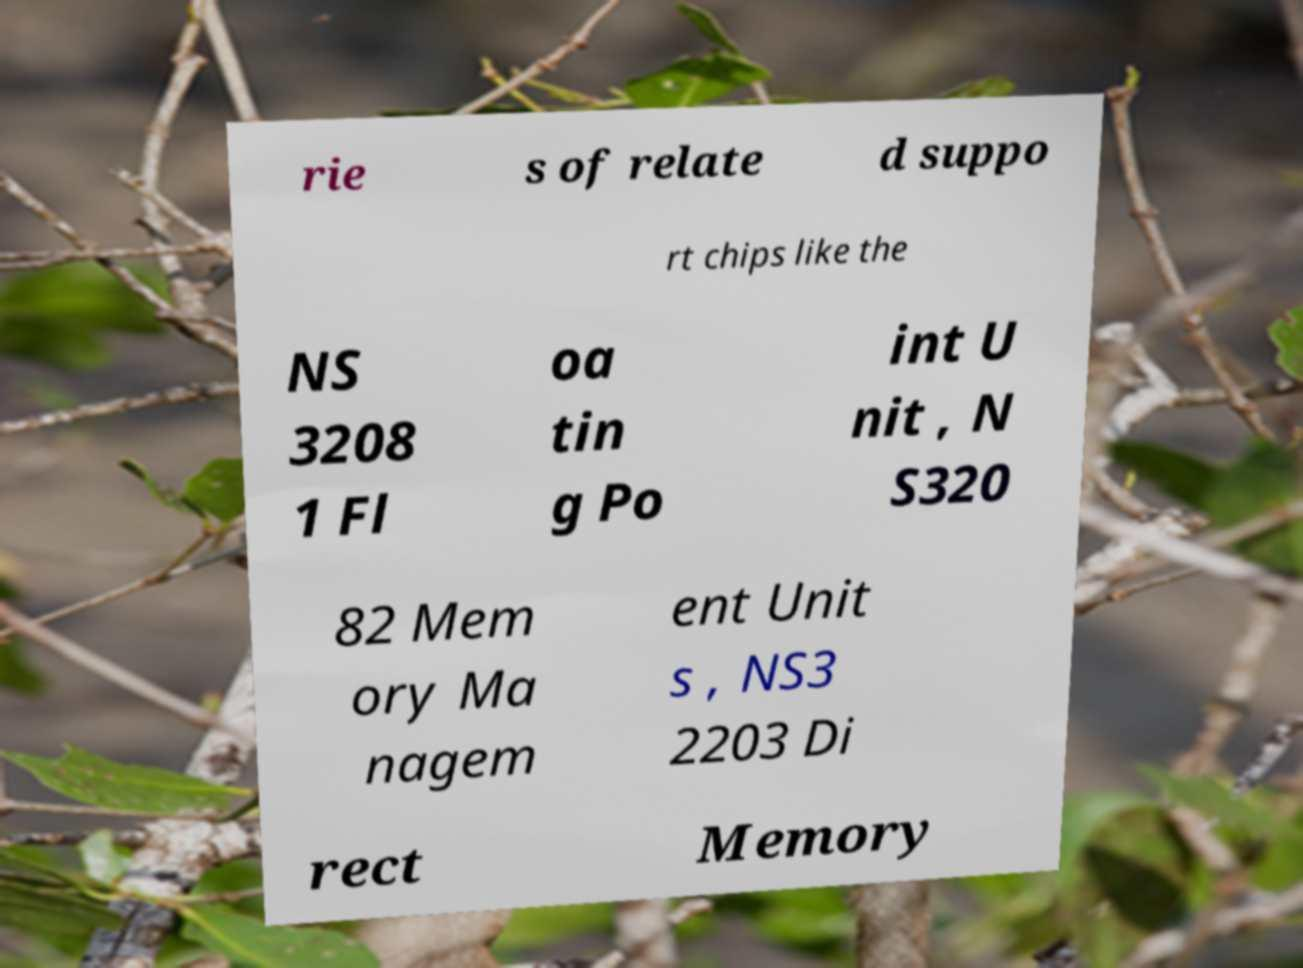Please identify and transcribe the text found in this image. rie s of relate d suppo rt chips like the NS 3208 1 Fl oa tin g Po int U nit , N S320 82 Mem ory Ma nagem ent Unit s , NS3 2203 Di rect Memory 